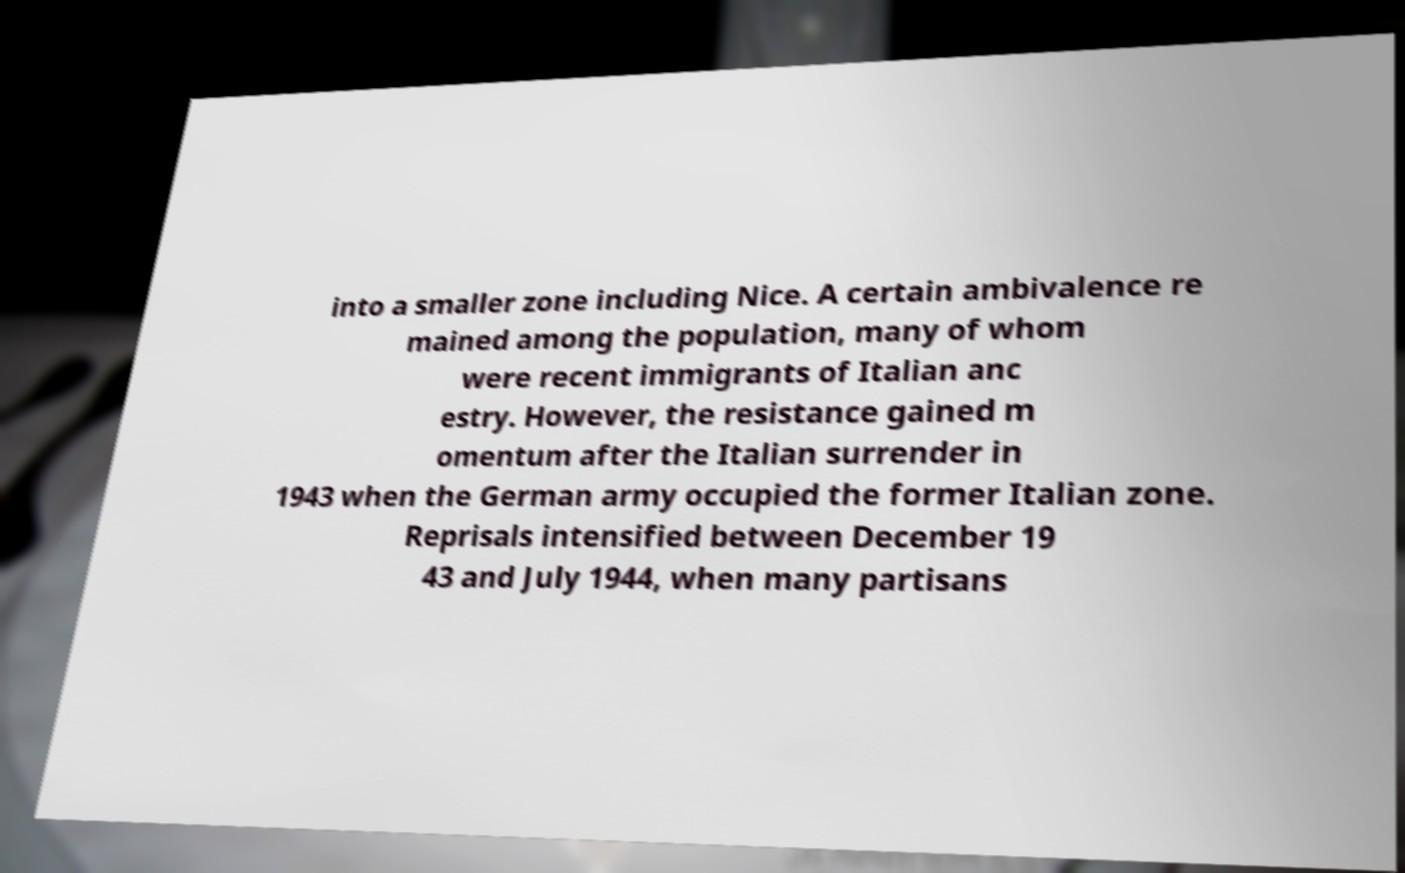Could you extract and type out the text from this image? into a smaller zone including Nice. A certain ambivalence re mained among the population, many of whom were recent immigrants of Italian anc estry. However, the resistance gained m omentum after the Italian surrender in 1943 when the German army occupied the former Italian zone. Reprisals intensified between December 19 43 and July 1944, when many partisans 